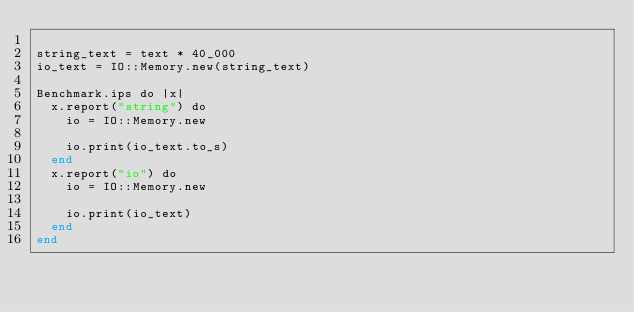Convert code to text. <code><loc_0><loc_0><loc_500><loc_500><_Crystal_>
string_text = text * 40_000
io_text = IO::Memory.new(string_text)

Benchmark.ips do |x|
  x.report("string") do
    io = IO::Memory.new

    io.print(io_text.to_s)
  end
  x.report("io") do
    io = IO::Memory.new

    io.print(io_text)
  end
end
</code> 